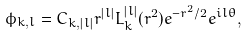<formula> <loc_0><loc_0><loc_500><loc_500>\phi _ { k , l } = C _ { k , | l | } r ^ { | l | } L _ { k } ^ { | l | } ( r ^ { 2 } ) e ^ { - r ^ { 2 } / 2 } e ^ { i l \theta } ,</formula> 